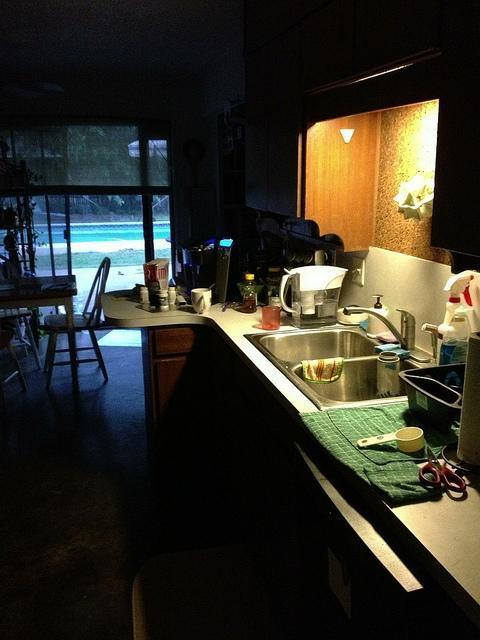How many people are wearing red shirt?
Give a very brief answer. 0. 